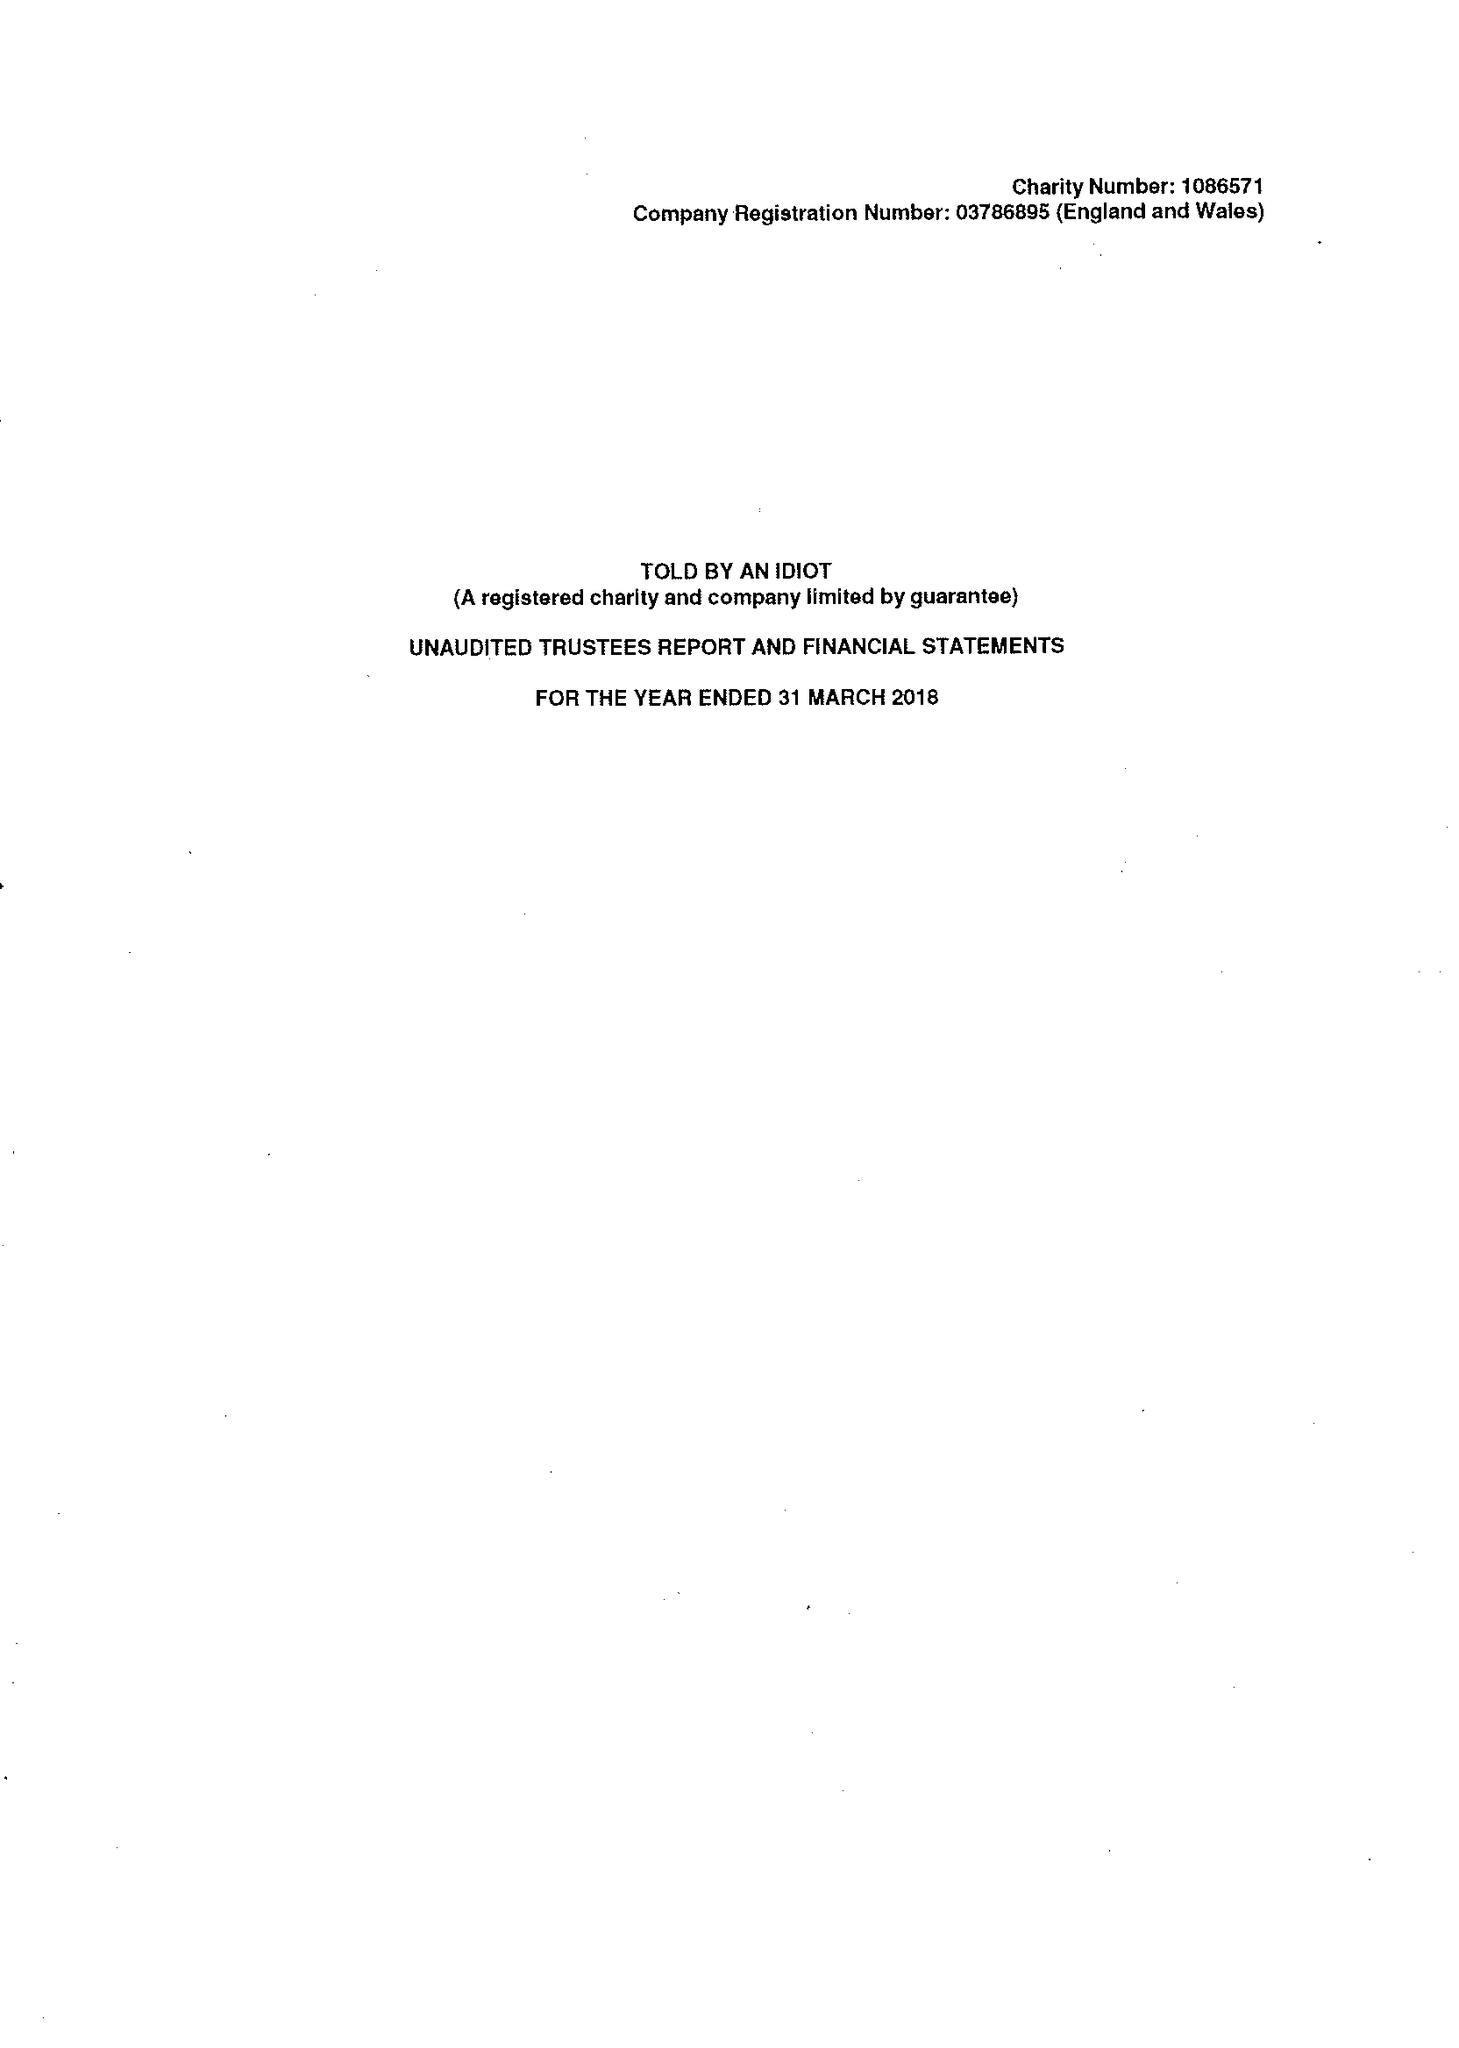What is the value for the charity_number?
Answer the question using a single word or phrase. 1086571 